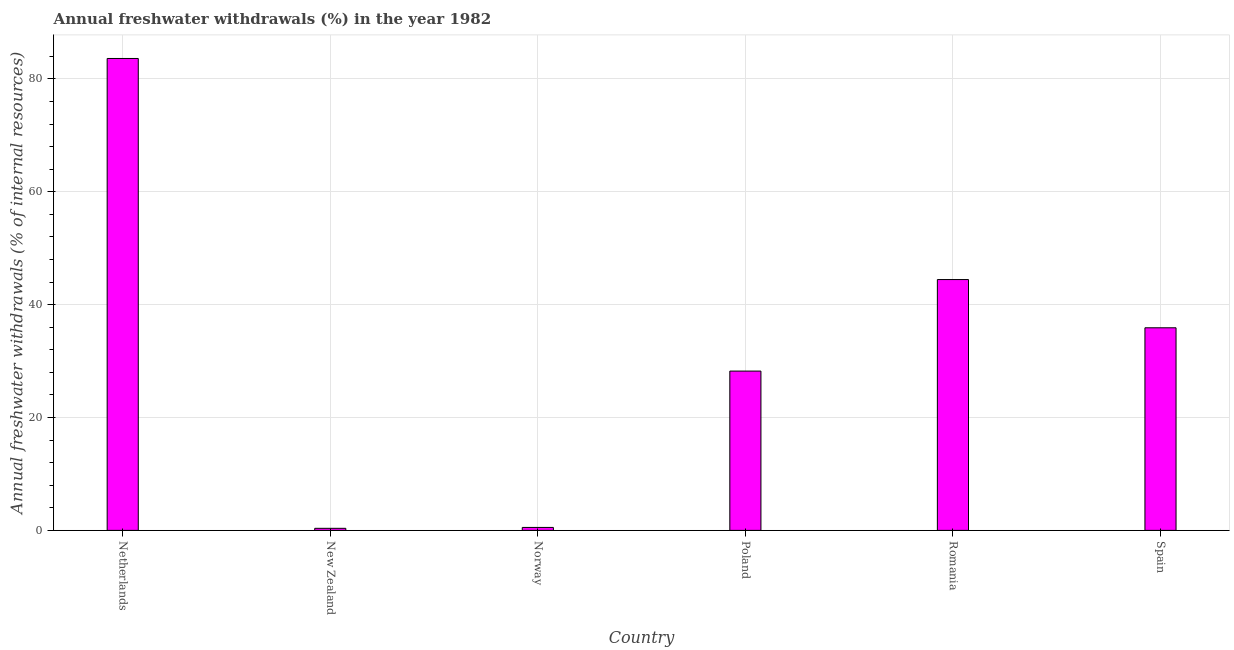Does the graph contain any zero values?
Keep it short and to the point. No. What is the title of the graph?
Ensure brevity in your answer.  Annual freshwater withdrawals (%) in the year 1982. What is the label or title of the Y-axis?
Your response must be concise. Annual freshwater withdrawals (% of internal resources). What is the annual freshwater withdrawals in New Zealand?
Provide a succinct answer. 0.37. Across all countries, what is the maximum annual freshwater withdrawals?
Your answer should be compact. 83.62. Across all countries, what is the minimum annual freshwater withdrawals?
Keep it short and to the point. 0.37. In which country was the annual freshwater withdrawals maximum?
Provide a succinct answer. Netherlands. In which country was the annual freshwater withdrawals minimum?
Your answer should be compact. New Zealand. What is the sum of the annual freshwater withdrawals?
Offer a very short reply. 193.08. What is the difference between the annual freshwater withdrawals in New Zealand and Norway?
Your answer should be compact. -0.16. What is the average annual freshwater withdrawals per country?
Your response must be concise. 32.18. What is the median annual freshwater withdrawals?
Keep it short and to the point. 32.06. In how many countries, is the annual freshwater withdrawals greater than 44 %?
Make the answer very short. 2. What is the ratio of the annual freshwater withdrawals in Netherlands to that in New Zealand?
Offer a very short reply. 227.86. Is the annual freshwater withdrawals in Netherlands less than that in Romania?
Provide a short and direct response. No. Is the difference between the annual freshwater withdrawals in Netherlands and Spain greater than the difference between any two countries?
Provide a short and direct response. No. What is the difference between the highest and the second highest annual freshwater withdrawals?
Give a very brief answer. 39.17. What is the difference between the highest and the lowest annual freshwater withdrawals?
Offer a terse response. 83.25. How many bars are there?
Your answer should be compact. 6. Are all the bars in the graph horizontal?
Ensure brevity in your answer.  No. What is the difference between two consecutive major ticks on the Y-axis?
Make the answer very short. 20. Are the values on the major ticks of Y-axis written in scientific E-notation?
Your response must be concise. No. What is the Annual freshwater withdrawals (% of internal resources) in Netherlands?
Your answer should be very brief. 83.62. What is the Annual freshwater withdrawals (% of internal resources) of New Zealand?
Offer a terse response. 0.37. What is the Annual freshwater withdrawals (% of internal resources) in Norway?
Provide a succinct answer. 0.52. What is the Annual freshwater withdrawals (% of internal resources) of Poland?
Give a very brief answer. 28.23. What is the Annual freshwater withdrawals (% of internal resources) of Romania?
Offer a very short reply. 44.44. What is the Annual freshwater withdrawals (% of internal resources) in Spain?
Provide a short and direct response. 35.9. What is the difference between the Annual freshwater withdrawals (% of internal resources) in Netherlands and New Zealand?
Your answer should be compact. 83.25. What is the difference between the Annual freshwater withdrawals (% of internal resources) in Netherlands and Norway?
Make the answer very short. 83.09. What is the difference between the Annual freshwater withdrawals (% of internal resources) in Netherlands and Poland?
Make the answer very short. 55.39. What is the difference between the Annual freshwater withdrawals (% of internal resources) in Netherlands and Romania?
Provide a succinct answer. 39.17. What is the difference between the Annual freshwater withdrawals (% of internal resources) in Netherlands and Spain?
Your answer should be very brief. 47.72. What is the difference between the Annual freshwater withdrawals (% of internal resources) in New Zealand and Norway?
Offer a very short reply. -0.16. What is the difference between the Annual freshwater withdrawals (% of internal resources) in New Zealand and Poland?
Give a very brief answer. -27.86. What is the difference between the Annual freshwater withdrawals (% of internal resources) in New Zealand and Romania?
Offer a terse response. -44.08. What is the difference between the Annual freshwater withdrawals (% of internal resources) in New Zealand and Spain?
Your answer should be very brief. -35.53. What is the difference between the Annual freshwater withdrawals (% of internal resources) in Norway and Poland?
Provide a succinct answer. -27.7. What is the difference between the Annual freshwater withdrawals (% of internal resources) in Norway and Romania?
Provide a succinct answer. -43.92. What is the difference between the Annual freshwater withdrawals (% of internal resources) in Norway and Spain?
Your answer should be very brief. -35.38. What is the difference between the Annual freshwater withdrawals (% of internal resources) in Poland and Romania?
Your answer should be compact. -16.22. What is the difference between the Annual freshwater withdrawals (% of internal resources) in Poland and Spain?
Make the answer very short. -7.67. What is the difference between the Annual freshwater withdrawals (% of internal resources) in Romania and Spain?
Make the answer very short. 8.55. What is the ratio of the Annual freshwater withdrawals (% of internal resources) in Netherlands to that in New Zealand?
Your answer should be very brief. 227.86. What is the ratio of the Annual freshwater withdrawals (% of internal resources) in Netherlands to that in Norway?
Make the answer very short. 159.71. What is the ratio of the Annual freshwater withdrawals (% of internal resources) in Netherlands to that in Poland?
Your response must be concise. 2.96. What is the ratio of the Annual freshwater withdrawals (% of internal resources) in Netherlands to that in Romania?
Keep it short and to the point. 1.88. What is the ratio of the Annual freshwater withdrawals (% of internal resources) in Netherlands to that in Spain?
Provide a succinct answer. 2.33. What is the ratio of the Annual freshwater withdrawals (% of internal resources) in New Zealand to that in Norway?
Provide a short and direct response. 0.7. What is the ratio of the Annual freshwater withdrawals (% of internal resources) in New Zealand to that in Poland?
Offer a terse response. 0.01. What is the ratio of the Annual freshwater withdrawals (% of internal resources) in New Zealand to that in Romania?
Make the answer very short. 0.01. What is the ratio of the Annual freshwater withdrawals (% of internal resources) in New Zealand to that in Spain?
Offer a very short reply. 0.01. What is the ratio of the Annual freshwater withdrawals (% of internal resources) in Norway to that in Poland?
Provide a short and direct response. 0.02. What is the ratio of the Annual freshwater withdrawals (% of internal resources) in Norway to that in Romania?
Your answer should be very brief. 0.01. What is the ratio of the Annual freshwater withdrawals (% of internal resources) in Norway to that in Spain?
Give a very brief answer. 0.01. What is the ratio of the Annual freshwater withdrawals (% of internal resources) in Poland to that in Romania?
Keep it short and to the point. 0.64. What is the ratio of the Annual freshwater withdrawals (% of internal resources) in Poland to that in Spain?
Your answer should be compact. 0.79. What is the ratio of the Annual freshwater withdrawals (% of internal resources) in Romania to that in Spain?
Make the answer very short. 1.24. 